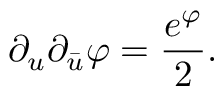<formula> <loc_0><loc_0><loc_500><loc_500>\partial _ { u } \partial _ { \bar { u } } \varphi = { \frac { e ^ { \varphi } } { 2 } } .</formula> 